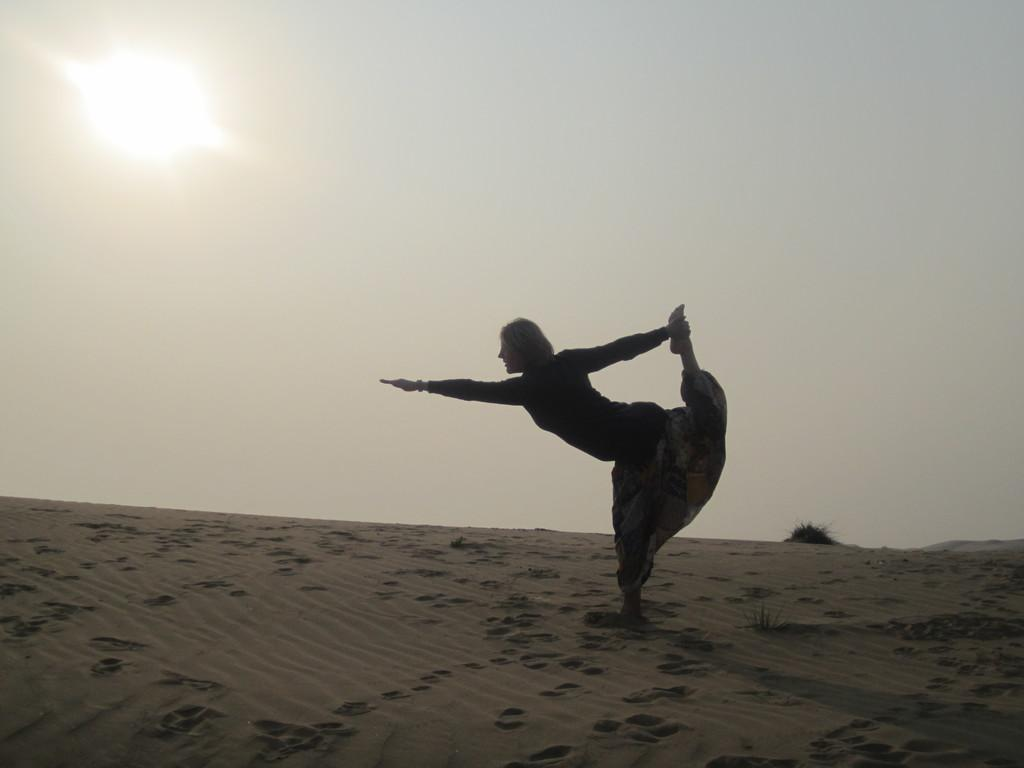Who is present in the image? There is a man in the image. Where is the man located? The man is standing in the desert. What is the man doing in the image? The man is doing yoga. What part of the natural environment is visible in the image? The sky is visible in the image. What type of locket can be seen around the man's neck in the image? There is no locket visible around the man's neck in the image. What type of desk is present in the image? There is no desk present in the image; it features a man doing yoga in the desert. 